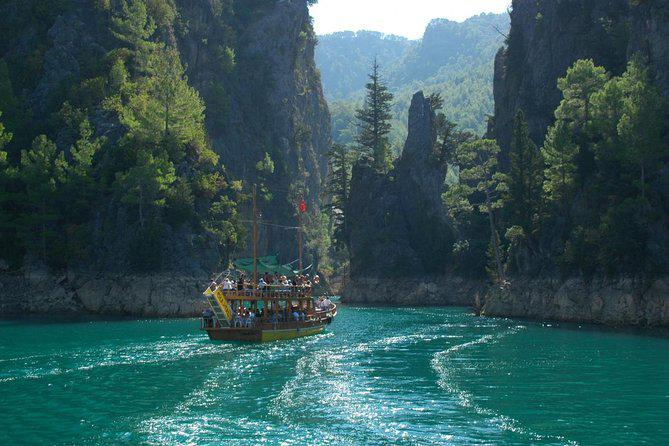What kind of landscape is depicted in this image? The image features a majestic landscape with a verdant gorge. High, rugged cliffs rise on either side of a serene, turquoise waterway that reflects the sun's rays, casting a sparkling effect on the water. What activities seem popular in this location? Given the presence of the boat filled with people, it suggests that guided boat tours are a popular activity, offering visitors a unique perspective of the breathtaking natural scenery and the chance to enjoy the water. 